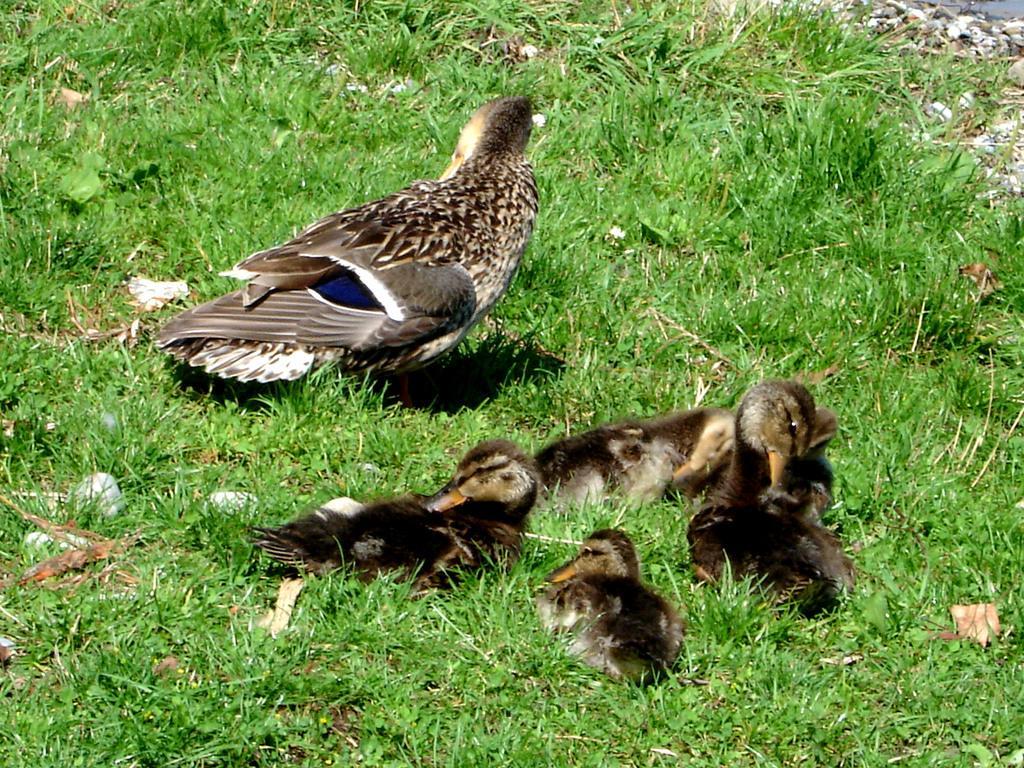Can you describe this image briefly? In this image I can see the ground, some grass on the ground and few birds which are brown, cream, blue and black in color. 